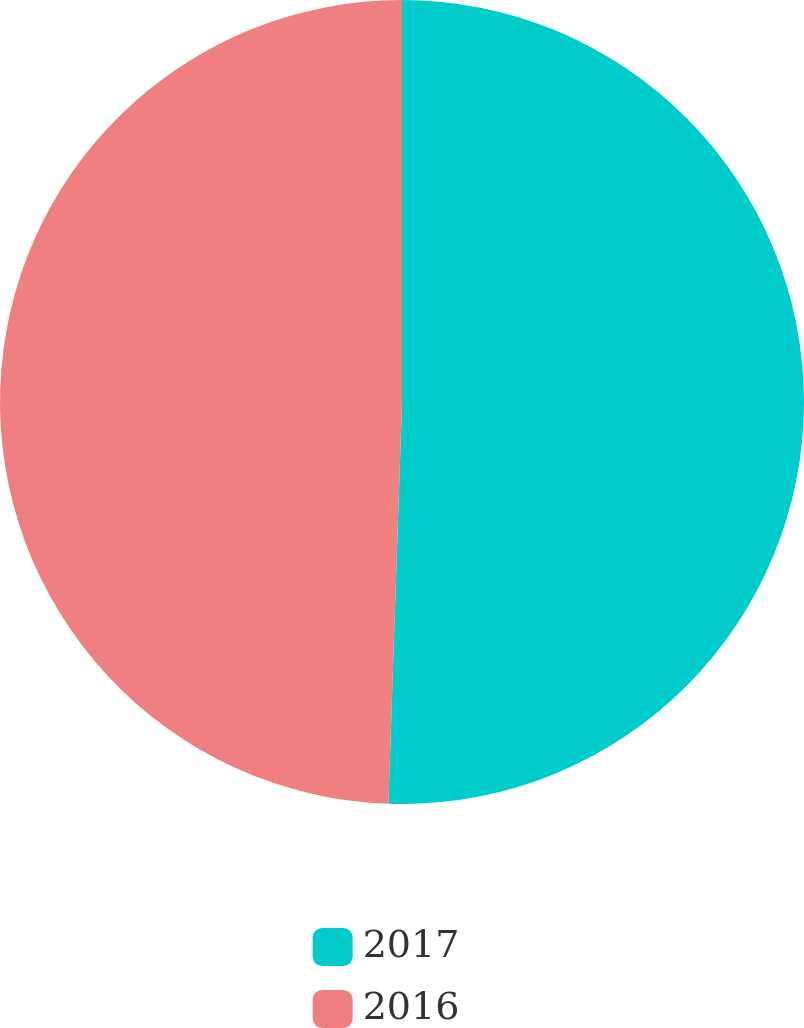<chart> <loc_0><loc_0><loc_500><loc_500><pie_chart><fcel>2017<fcel>2016<nl><fcel>50.54%<fcel>49.46%<nl></chart> 